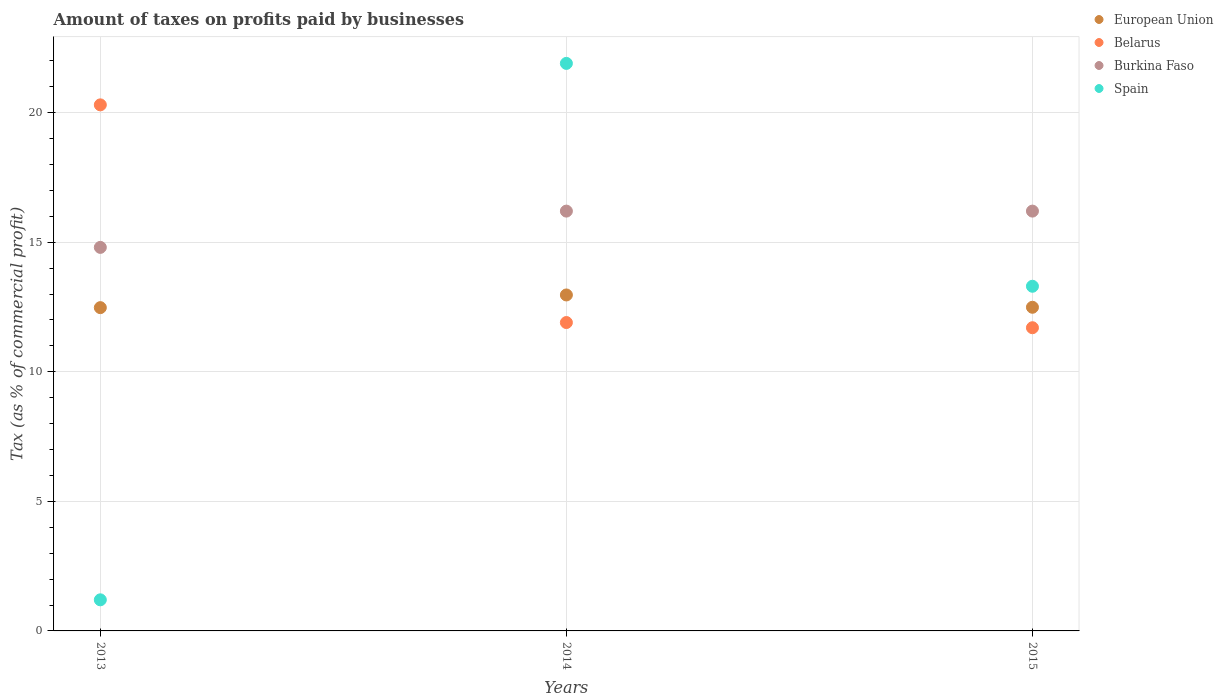How many different coloured dotlines are there?
Provide a succinct answer. 4. Is the number of dotlines equal to the number of legend labels?
Your answer should be very brief. Yes. What is the percentage of taxes paid by businesses in Burkina Faso in 2015?
Provide a short and direct response. 16.2. Across all years, what is the maximum percentage of taxes paid by businesses in Burkina Faso?
Provide a short and direct response. 16.2. In which year was the percentage of taxes paid by businesses in Belarus minimum?
Your response must be concise. 2015. What is the total percentage of taxes paid by businesses in Burkina Faso in the graph?
Offer a very short reply. 47.2. What is the difference between the percentage of taxes paid by businesses in Belarus in 2015 and the percentage of taxes paid by businesses in Burkina Faso in 2013?
Provide a succinct answer. -3.1. What is the average percentage of taxes paid by businesses in Spain per year?
Make the answer very short. 12.13. In the year 2015, what is the difference between the percentage of taxes paid by businesses in Spain and percentage of taxes paid by businesses in Burkina Faso?
Keep it short and to the point. -2.9. In how many years, is the percentage of taxes paid by businesses in Belarus greater than 18 %?
Make the answer very short. 1. What is the ratio of the percentage of taxes paid by businesses in Belarus in 2013 to that in 2014?
Ensure brevity in your answer.  1.71. Is the percentage of taxes paid by businesses in Spain in 2013 less than that in 2014?
Give a very brief answer. Yes. Is the difference between the percentage of taxes paid by businesses in Spain in 2014 and 2015 greater than the difference between the percentage of taxes paid by businesses in Burkina Faso in 2014 and 2015?
Your response must be concise. Yes. What is the difference between the highest and the second highest percentage of taxes paid by businesses in Spain?
Offer a terse response. 8.6. What is the difference between the highest and the lowest percentage of taxes paid by businesses in Belarus?
Offer a terse response. 8.6. Is the sum of the percentage of taxes paid by businesses in Spain in 2014 and 2015 greater than the maximum percentage of taxes paid by businesses in Burkina Faso across all years?
Make the answer very short. Yes. Is the percentage of taxes paid by businesses in Spain strictly less than the percentage of taxes paid by businesses in Burkina Faso over the years?
Provide a succinct answer. No. What is the difference between two consecutive major ticks on the Y-axis?
Provide a short and direct response. 5. Does the graph contain grids?
Give a very brief answer. Yes. How are the legend labels stacked?
Make the answer very short. Vertical. What is the title of the graph?
Your response must be concise. Amount of taxes on profits paid by businesses. Does "Ethiopia" appear as one of the legend labels in the graph?
Your answer should be compact. No. What is the label or title of the Y-axis?
Your answer should be very brief. Tax (as % of commercial profit). What is the Tax (as % of commercial profit) in European Union in 2013?
Your answer should be compact. 12.47. What is the Tax (as % of commercial profit) of Belarus in 2013?
Offer a terse response. 20.3. What is the Tax (as % of commercial profit) in Burkina Faso in 2013?
Give a very brief answer. 14.8. What is the Tax (as % of commercial profit) of Spain in 2013?
Keep it short and to the point. 1.2. What is the Tax (as % of commercial profit) of European Union in 2014?
Your answer should be very brief. 12.96. What is the Tax (as % of commercial profit) of Burkina Faso in 2014?
Keep it short and to the point. 16.2. What is the Tax (as % of commercial profit) in Spain in 2014?
Offer a terse response. 21.9. What is the Tax (as % of commercial profit) of European Union in 2015?
Provide a short and direct response. 12.49. What is the Tax (as % of commercial profit) in Belarus in 2015?
Provide a succinct answer. 11.7. What is the Tax (as % of commercial profit) of Burkina Faso in 2015?
Make the answer very short. 16.2. Across all years, what is the maximum Tax (as % of commercial profit) of European Union?
Your answer should be very brief. 12.96. Across all years, what is the maximum Tax (as % of commercial profit) in Belarus?
Provide a short and direct response. 20.3. Across all years, what is the maximum Tax (as % of commercial profit) of Spain?
Offer a terse response. 21.9. Across all years, what is the minimum Tax (as % of commercial profit) of European Union?
Provide a succinct answer. 12.47. Across all years, what is the minimum Tax (as % of commercial profit) in Belarus?
Provide a succinct answer. 11.7. What is the total Tax (as % of commercial profit) of European Union in the graph?
Provide a short and direct response. 37.93. What is the total Tax (as % of commercial profit) of Belarus in the graph?
Keep it short and to the point. 43.9. What is the total Tax (as % of commercial profit) in Burkina Faso in the graph?
Offer a very short reply. 47.2. What is the total Tax (as % of commercial profit) in Spain in the graph?
Offer a very short reply. 36.4. What is the difference between the Tax (as % of commercial profit) of European Union in 2013 and that in 2014?
Provide a short and direct response. -0.49. What is the difference between the Tax (as % of commercial profit) of Belarus in 2013 and that in 2014?
Your answer should be very brief. 8.4. What is the difference between the Tax (as % of commercial profit) of Spain in 2013 and that in 2014?
Keep it short and to the point. -20.7. What is the difference between the Tax (as % of commercial profit) of European Union in 2013 and that in 2015?
Offer a very short reply. -0.01. What is the difference between the Tax (as % of commercial profit) of Burkina Faso in 2013 and that in 2015?
Provide a short and direct response. -1.4. What is the difference between the Tax (as % of commercial profit) in Spain in 2013 and that in 2015?
Keep it short and to the point. -12.1. What is the difference between the Tax (as % of commercial profit) of European Union in 2014 and that in 2015?
Provide a succinct answer. 0.47. What is the difference between the Tax (as % of commercial profit) in Belarus in 2014 and that in 2015?
Ensure brevity in your answer.  0.2. What is the difference between the Tax (as % of commercial profit) in European Union in 2013 and the Tax (as % of commercial profit) in Belarus in 2014?
Your answer should be compact. 0.57. What is the difference between the Tax (as % of commercial profit) of European Union in 2013 and the Tax (as % of commercial profit) of Burkina Faso in 2014?
Your answer should be very brief. -3.73. What is the difference between the Tax (as % of commercial profit) of European Union in 2013 and the Tax (as % of commercial profit) of Spain in 2014?
Offer a very short reply. -9.43. What is the difference between the Tax (as % of commercial profit) of Belarus in 2013 and the Tax (as % of commercial profit) of Spain in 2014?
Make the answer very short. -1.6. What is the difference between the Tax (as % of commercial profit) of European Union in 2013 and the Tax (as % of commercial profit) of Belarus in 2015?
Your answer should be very brief. 0.78. What is the difference between the Tax (as % of commercial profit) of European Union in 2013 and the Tax (as % of commercial profit) of Burkina Faso in 2015?
Provide a succinct answer. -3.73. What is the difference between the Tax (as % of commercial profit) of European Union in 2013 and the Tax (as % of commercial profit) of Spain in 2015?
Your response must be concise. -0.82. What is the difference between the Tax (as % of commercial profit) in Belarus in 2013 and the Tax (as % of commercial profit) in Burkina Faso in 2015?
Make the answer very short. 4.1. What is the difference between the Tax (as % of commercial profit) in Belarus in 2013 and the Tax (as % of commercial profit) in Spain in 2015?
Your answer should be very brief. 7. What is the difference between the Tax (as % of commercial profit) in Burkina Faso in 2013 and the Tax (as % of commercial profit) in Spain in 2015?
Keep it short and to the point. 1.5. What is the difference between the Tax (as % of commercial profit) in European Union in 2014 and the Tax (as % of commercial profit) in Belarus in 2015?
Offer a terse response. 1.26. What is the difference between the Tax (as % of commercial profit) in European Union in 2014 and the Tax (as % of commercial profit) in Burkina Faso in 2015?
Give a very brief answer. -3.24. What is the difference between the Tax (as % of commercial profit) of European Union in 2014 and the Tax (as % of commercial profit) of Spain in 2015?
Your answer should be compact. -0.34. What is the difference between the Tax (as % of commercial profit) in Belarus in 2014 and the Tax (as % of commercial profit) in Burkina Faso in 2015?
Provide a succinct answer. -4.3. What is the difference between the Tax (as % of commercial profit) of Belarus in 2014 and the Tax (as % of commercial profit) of Spain in 2015?
Your answer should be compact. -1.4. What is the difference between the Tax (as % of commercial profit) of Burkina Faso in 2014 and the Tax (as % of commercial profit) of Spain in 2015?
Your response must be concise. 2.9. What is the average Tax (as % of commercial profit) in European Union per year?
Your answer should be compact. 12.64. What is the average Tax (as % of commercial profit) of Belarus per year?
Give a very brief answer. 14.63. What is the average Tax (as % of commercial profit) of Burkina Faso per year?
Offer a terse response. 15.73. What is the average Tax (as % of commercial profit) of Spain per year?
Offer a very short reply. 12.13. In the year 2013, what is the difference between the Tax (as % of commercial profit) of European Union and Tax (as % of commercial profit) of Belarus?
Ensure brevity in your answer.  -7.83. In the year 2013, what is the difference between the Tax (as % of commercial profit) in European Union and Tax (as % of commercial profit) in Burkina Faso?
Make the answer very short. -2.33. In the year 2013, what is the difference between the Tax (as % of commercial profit) in European Union and Tax (as % of commercial profit) in Spain?
Your answer should be very brief. 11.28. In the year 2013, what is the difference between the Tax (as % of commercial profit) in Belarus and Tax (as % of commercial profit) in Spain?
Offer a very short reply. 19.1. In the year 2014, what is the difference between the Tax (as % of commercial profit) of European Union and Tax (as % of commercial profit) of Belarus?
Your response must be concise. 1.06. In the year 2014, what is the difference between the Tax (as % of commercial profit) of European Union and Tax (as % of commercial profit) of Burkina Faso?
Offer a very short reply. -3.24. In the year 2014, what is the difference between the Tax (as % of commercial profit) of European Union and Tax (as % of commercial profit) of Spain?
Ensure brevity in your answer.  -8.94. In the year 2014, what is the difference between the Tax (as % of commercial profit) in Belarus and Tax (as % of commercial profit) in Burkina Faso?
Your answer should be very brief. -4.3. In the year 2015, what is the difference between the Tax (as % of commercial profit) in European Union and Tax (as % of commercial profit) in Belarus?
Provide a succinct answer. 0.79. In the year 2015, what is the difference between the Tax (as % of commercial profit) of European Union and Tax (as % of commercial profit) of Burkina Faso?
Your answer should be very brief. -3.71. In the year 2015, what is the difference between the Tax (as % of commercial profit) in European Union and Tax (as % of commercial profit) in Spain?
Give a very brief answer. -0.81. In the year 2015, what is the difference between the Tax (as % of commercial profit) in Belarus and Tax (as % of commercial profit) in Burkina Faso?
Your answer should be very brief. -4.5. In the year 2015, what is the difference between the Tax (as % of commercial profit) of Belarus and Tax (as % of commercial profit) of Spain?
Give a very brief answer. -1.6. In the year 2015, what is the difference between the Tax (as % of commercial profit) of Burkina Faso and Tax (as % of commercial profit) of Spain?
Keep it short and to the point. 2.9. What is the ratio of the Tax (as % of commercial profit) in European Union in 2013 to that in 2014?
Offer a terse response. 0.96. What is the ratio of the Tax (as % of commercial profit) of Belarus in 2013 to that in 2014?
Your answer should be very brief. 1.71. What is the ratio of the Tax (as % of commercial profit) of Burkina Faso in 2013 to that in 2014?
Ensure brevity in your answer.  0.91. What is the ratio of the Tax (as % of commercial profit) of Spain in 2013 to that in 2014?
Give a very brief answer. 0.05. What is the ratio of the Tax (as % of commercial profit) in Belarus in 2013 to that in 2015?
Your answer should be very brief. 1.74. What is the ratio of the Tax (as % of commercial profit) in Burkina Faso in 2013 to that in 2015?
Provide a short and direct response. 0.91. What is the ratio of the Tax (as % of commercial profit) in Spain in 2013 to that in 2015?
Provide a short and direct response. 0.09. What is the ratio of the Tax (as % of commercial profit) in European Union in 2014 to that in 2015?
Make the answer very short. 1.04. What is the ratio of the Tax (as % of commercial profit) in Belarus in 2014 to that in 2015?
Make the answer very short. 1.02. What is the ratio of the Tax (as % of commercial profit) in Burkina Faso in 2014 to that in 2015?
Provide a short and direct response. 1. What is the ratio of the Tax (as % of commercial profit) of Spain in 2014 to that in 2015?
Your answer should be very brief. 1.65. What is the difference between the highest and the second highest Tax (as % of commercial profit) of European Union?
Your answer should be compact. 0.47. What is the difference between the highest and the lowest Tax (as % of commercial profit) in European Union?
Your response must be concise. 0.49. What is the difference between the highest and the lowest Tax (as % of commercial profit) of Spain?
Offer a very short reply. 20.7. 